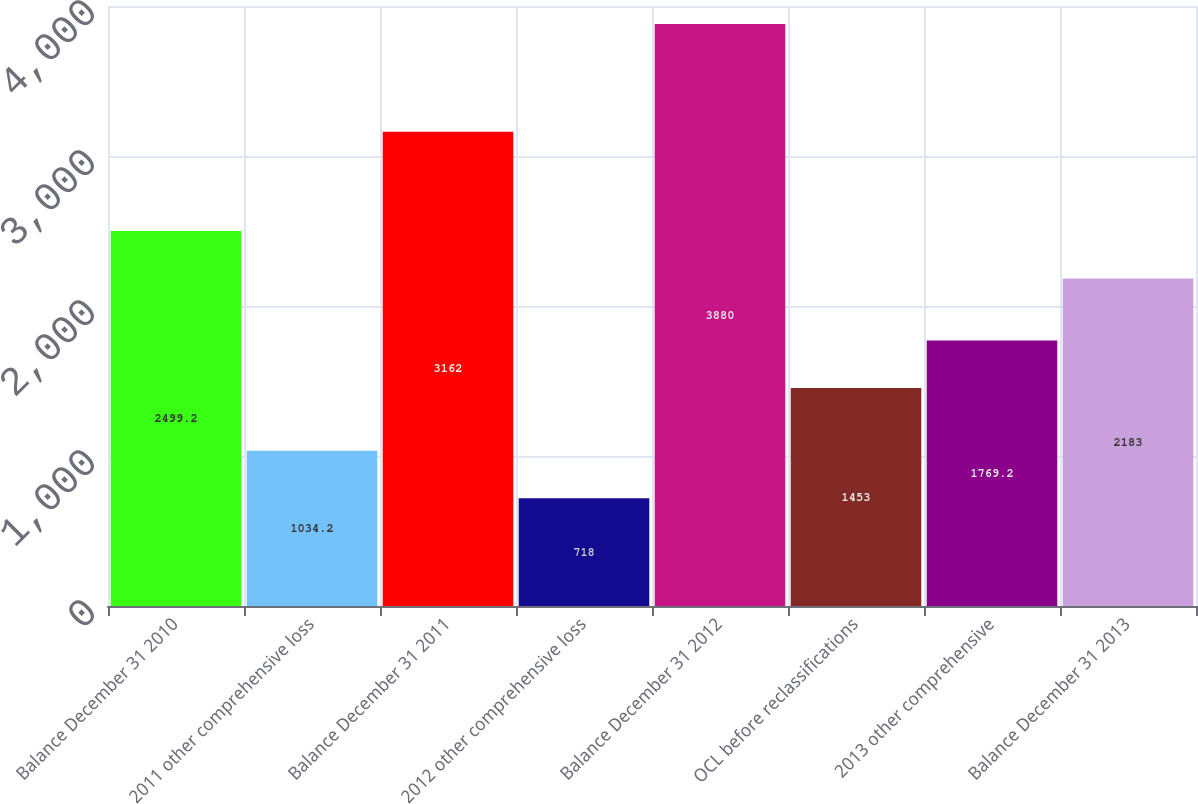<chart> <loc_0><loc_0><loc_500><loc_500><bar_chart><fcel>Balance December 31 2010<fcel>2011 other comprehensive loss<fcel>Balance December 31 2011<fcel>2012 other comprehensive loss<fcel>Balance December 31 2012<fcel>OCL before reclassifications<fcel>2013 other comprehensive<fcel>Balance December 31 2013<nl><fcel>2499.2<fcel>1034.2<fcel>3162<fcel>718<fcel>3880<fcel>1453<fcel>1769.2<fcel>2183<nl></chart> 